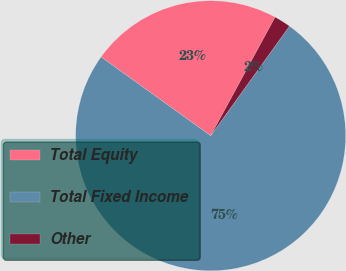Convert chart. <chart><loc_0><loc_0><loc_500><loc_500><pie_chart><fcel>Total Equity<fcel>Total Fixed Income<fcel>Other<nl><fcel>23.0%<fcel>75.0%<fcel>2.0%<nl></chart> 